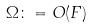<formula> <loc_0><loc_0><loc_500><loc_500>\Omega \colon = O ( F )</formula> 